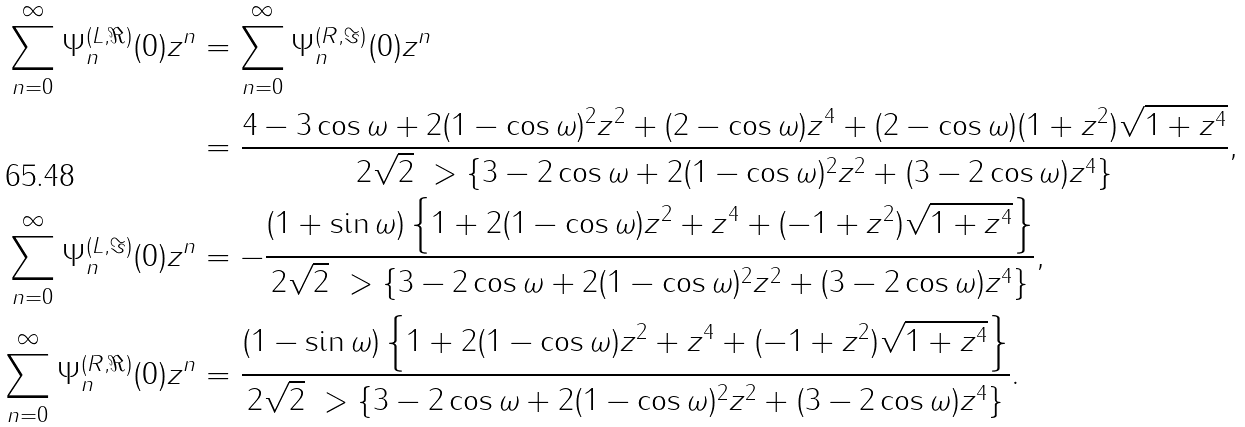Convert formula to latex. <formula><loc_0><loc_0><loc_500><loc_500>\sum _ { n = 0 } ^ { \infty } \Psi _ { n } ^ { ( L , \Re ) } ( 0 ) z ^ { n } & = \sum _ { n = 0 } ^ { \infty } \Psi _ { n } ^ { ( R , \Im ) } ( 0 ) z ^ { n } \\ & = \frac { 4 - 3 \cos \omega + 2 ( 1 - \cos \omega ) ^ { 2 } z ^ { 2 } + ( 2 - \cos \omega ) z ^ { 4 } + ( 2 - \cos \omega ) ( 1 + z ^ { 2 } ) \sqrt { 1 + z ^ { 4 } } } { 2 \sqrt { 2 } \ > \left \{ 3 - 2 \cos \omega + 2 ( 1 - \cos \omega ) ^ { 2 } z ^ { 2 } + ( 3 - 2 \cos \omega ) z ^ { 4 } \right \} } , \\ \sum _ { n = 0 } ^ { \infty } \Psi _ { n } ^ { ( L , \Im ) } ( 0 ) z ^ { n } & = - \frac { ( 1 + \sin \omega ) \left \{ 1 + 2 ( 1 - \cos \omega ) z ^ { 2 } + z ^ { 4 } + ( - 1 + z ^ { 2 } ) \sqrt { 1 + z ^ { 4 } } \right \} } { 2 \sqrt { 2 } \ > \left \{ 3 - 2 \cos \omega + 2 ( 1 - \cos \omega ) ^ { 2 } z ^ { 2 } + ( 3 - 2 \cos \omega ) z ^ { 4 } \right \} } , \\ \sum _ { n = 0 } ^ { \infty } \Psi _ { n } ^ { ( R , \Re ) } ( 0 ) z ^ { n } & = \frac { ( 1 - \sin \omega ) \left \{ 1 + 2 ( 1 - \cos \omega ) z ^ { 2 } + z ^ { 4 } + ( - 1 + z ^ { 2 } ) \sqrt { 1 + z ^ { 4 } } \right \} } { 2 \sqrt { 2 } \ > \left \{ 3 - 2 \cos \omega + 2 ( 1 - \cos \omega ) ^ { 2 } z ^ { 2 } + ( 3 - 2 \cos \omega ) z ^ { 4 } \right \} } .</formula> 